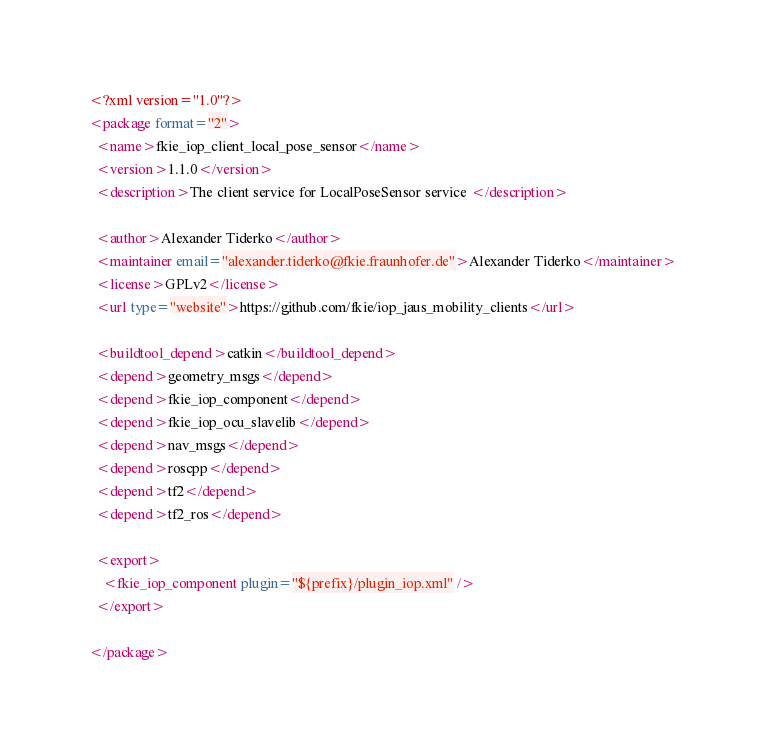Convert code to text. <code><loc_0><loc_0><loc_500><loc_500><_XML_><?xml version="1.0"?>
<package format="2">
  <name>fkie_iop_client_local_pose_sensor</name>
  <version>1.1.0</version>
  <description>The client service for LocalPoseSensor service </description>

  <author>Alexander Tiderko</author>
  <maintainer email="alexander.tiderko@fkie.fraunhofer.de">Alexander Tiderko</maintainer>
  <license>GPLv2</license>
  <url type="website">https://github.com/fkie/iop_jaus_mobility_clients</url>

  <buildtool_depend>catkin</buildtool_depend>
  <depend>geometry_msgs</depend>
  <depend>fkie_iop_component</depend>
  <depend>fkie_iop_ocu_slavelib</depend>
  <depend>nav_msgs</depend>
  <depend>roscpp</depend>
  <depend>tf2</depend>
  <depend>tf2_ros</depend>

  <export>
    <fkie_iop_component plugin="${prefix}/plugin_iop.xml" />
  </export>

</package>
</code> 